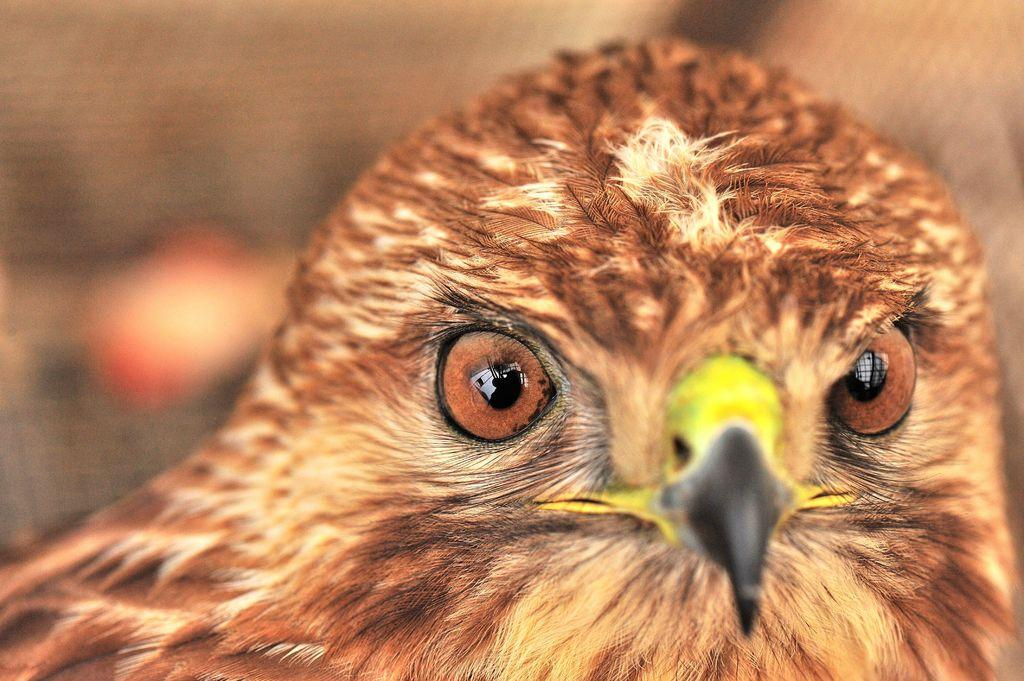What is the main subject of the image? The main subject of the image is a bird's head. Can you describe the background of the image? The background of the image is blurred. What type of shoe can be seen in the image? There is no shoe present in the image; it features a bird's head with a blurred background. How does the bird's head interact with the ink in the image? There is no ink present in the image; it only features a bird's head with a blurred background. 